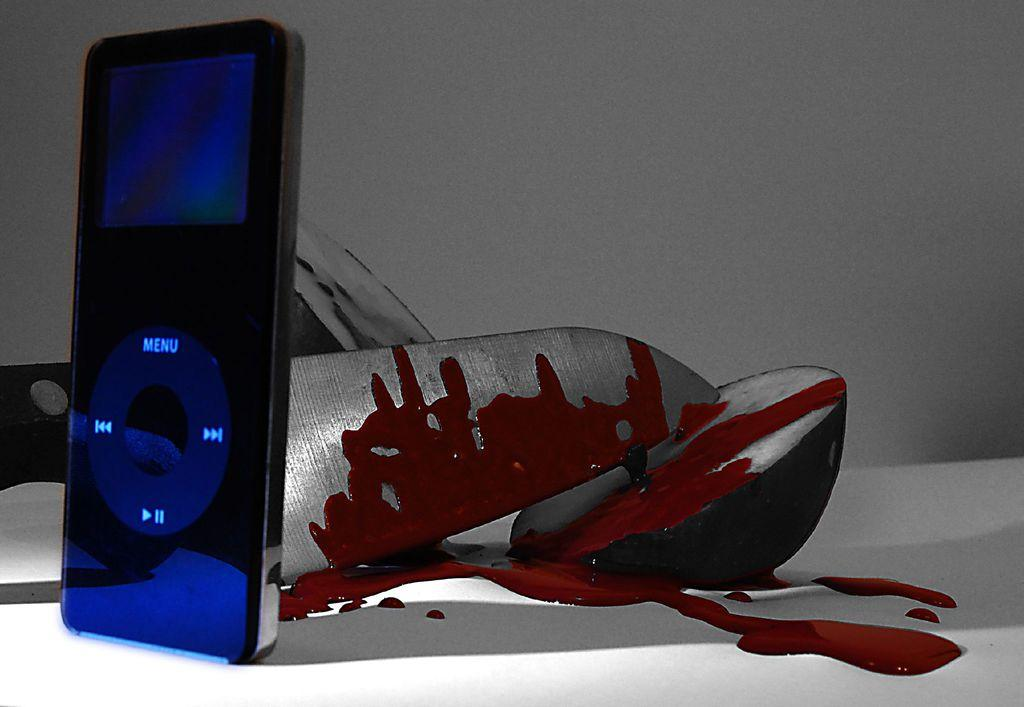What is located in the center of the image? There is a table in the center of the image. What electronic device can be seen on the table? An iPod is present on the table. What utensil is on the table? A knife is on the table. What substance is present on the table that is not typical for a table setting? There is blood on the table. What can be seen in the background of the image? There is a wall in the background of the image. Can you see a cow exchanging pleasantries with the iPod by the sea in the image? No, there is no cow, exchange, or sea present in the image. 